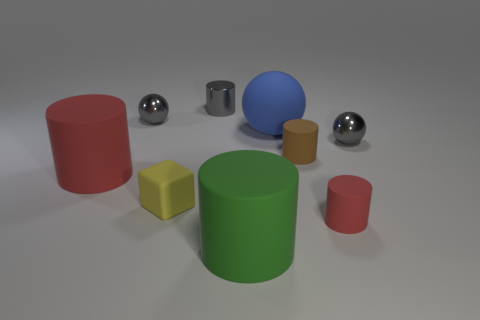What is the color of the block that is made of the same material as the small red cylinder?
Give a very brief answer. Yellow. Is the number of rubber things that are on the left side of the large red object less than the number of small shiny balls that are in front of the tiny yellow thing?
Offer a terse response. No. How many balls have the same color as the small block?
Make the answer very short. 0. What number of tiny metal spheres are both right of the big green object and left of the block?
Give a very brief answer. 0. There is a cylinder that is behind the ball that is in front of the large blue rubber ball; what is its material?
Ensure brevity in your answer.  Metal. Are there any green cylinders that have the same material as the blue sphere?
Make the answer very short. Yes. What is the material of the red cylinder that is the same size as the green rubber cylinder?
Your response must be concise. Rubber. What size is the object that is behind the small metal ball that is left of the red cylinder that is in front of the yellow rubber cube?
Offer a terse response. Small. Are there any large blue matte spheres behind the cylinder that is to the left of the tiny gray shiny cylinder?
Ensure brevity in your answer.  Yes. Is the shape of the green thing the same as the large object behind the big red matte cylinder?
Make the answer very short. No. 